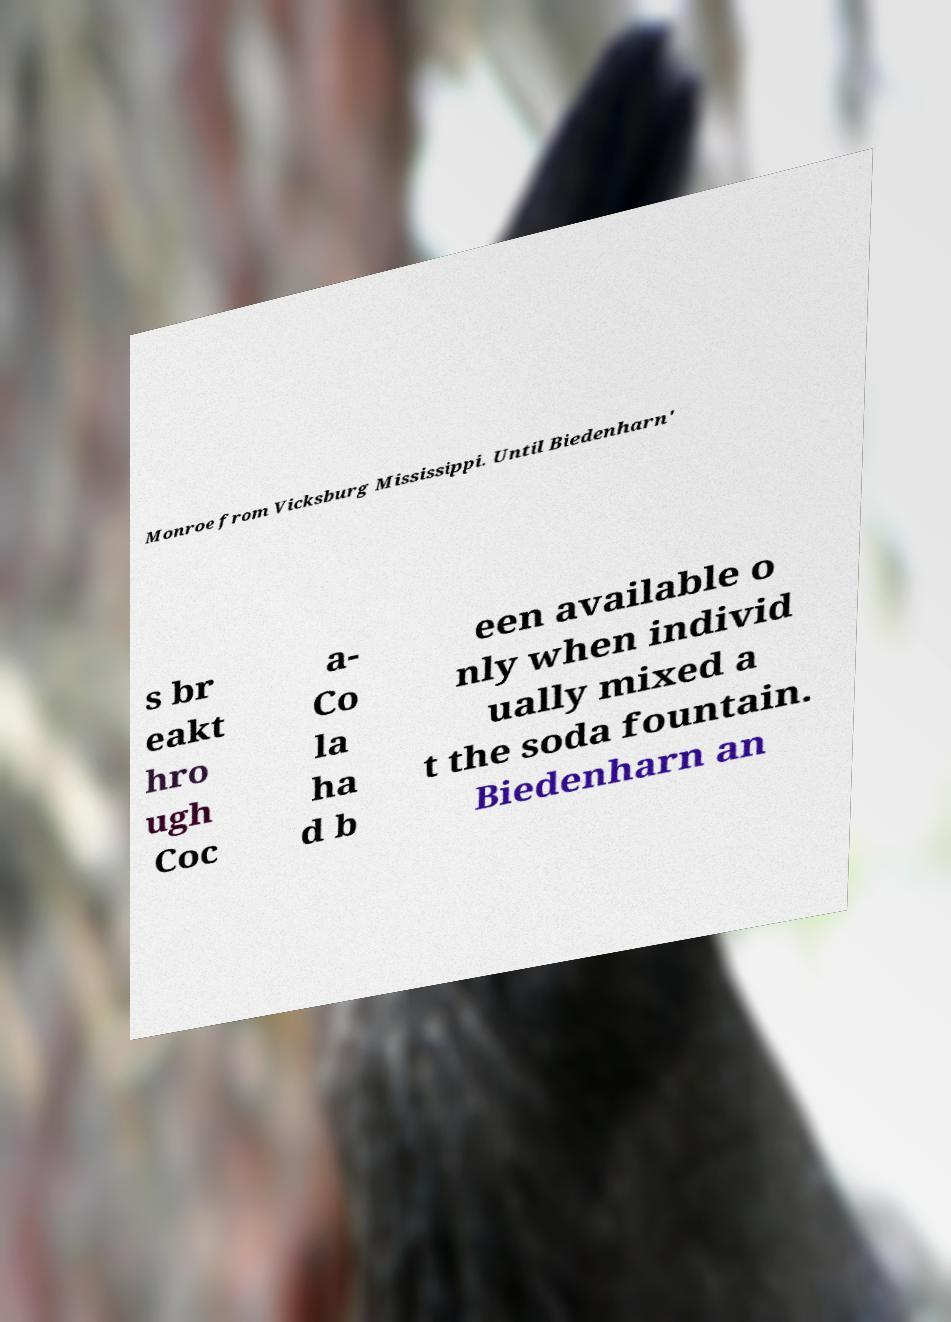Can you read and provide the text displayed in the image?This photo seems to have some interesting text. Can you extract and type it out for me? Monroe from Vicksburg Mississippi. Until Biedenharn' s br eakt hro ugh Coc a- Co la ha d b een available o nly when individ ually mixed a t the soda fountain. Biedenharn an 